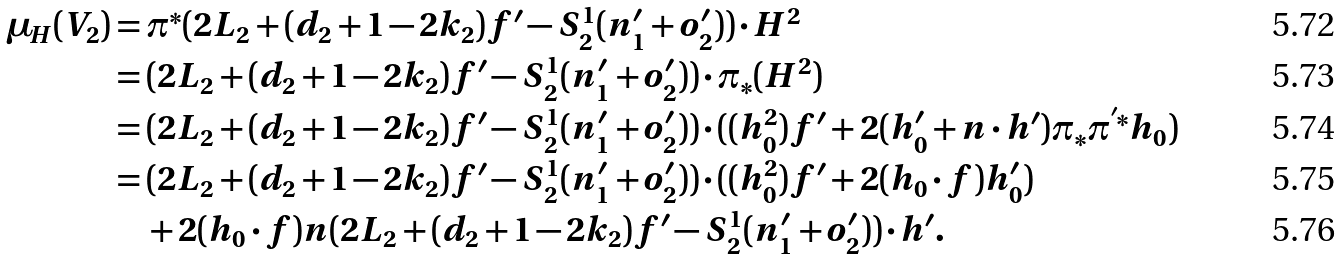<formula> <loc_0><loc_0><loc_500><loc_500>\mu _ { H } ( V _ { 2 } ) & = \pi ^ { * } ( 2 L _ { 2 } + ( d _ { 2 } + 1 - 2 k _ { 2 } ) f ^ { \prime } - S _ { 2 } ^ { 1 } ( n _ { 1 } ^ { \prime } + o _ { 2 } ^ { \prime } ) ) \cdot H ^ { 2 } \\ & = ( 2 L _ { 2 } + ( d _ { 2 } + 1 - 2 k _ { 2 } ) f ^ { \prime } - S _ { 2 } ^ { 1 } ( n _ { 1 } ^ { \prime } + o _ { 2 } ^ { \prime } ) ) \cdot \pi _ { * } ( H ^ { 2 } ) \\ & = ( 2 L _ { 2 } + ( d _ { 2 } + 1 - 2 k _ { 2 } ) f ^ { \prime } - S _ { 2 } ^ { 1 } ( n _ { 1 } ^ { \prime } + o _ { 2 } ^ { \prime } ) ) \cdot ( ( h _ { 0 } ^ { 2 } ) f ^ { \prime } + 2 ( h _ { 0 } ^ { \prime } + n \cdot h ^ { \prime } ) \pi _ { * } \pi ^ { ^ { \prime } * } h _ { 0 } ) \\ & = ( 2 L _ { 2 } + ( d _ { 2 } + 1 - 2 k _ { 2 } ) f ^ { \prime } - S _ { 2 } ^ { 1 } ( n _ { 1 } ^ { \prime } + o _ { 2 } ^ { \prime } ) ) \cdot ( ( h _ { 0 } ^ { 2 } ) f ^ { \prime } + 2 ( h _ { 0 } \cdot f ) h _ { 0 } ^ { \prime } ) \\ & \quad + 2 ( h _ { 0 } \cdot f ) n ( 2 L _ { 2 } + ( d _ { 2 } + 1 - 2 k _ { 2 } ) f ^ { \prime } - S _ { 2 } ^ { 1 } ( n _ { 1 } ^ { \prime } + o _ { 2 } ^ { \prime } ) ) \cdot h ^ { \prime } .</formula> 